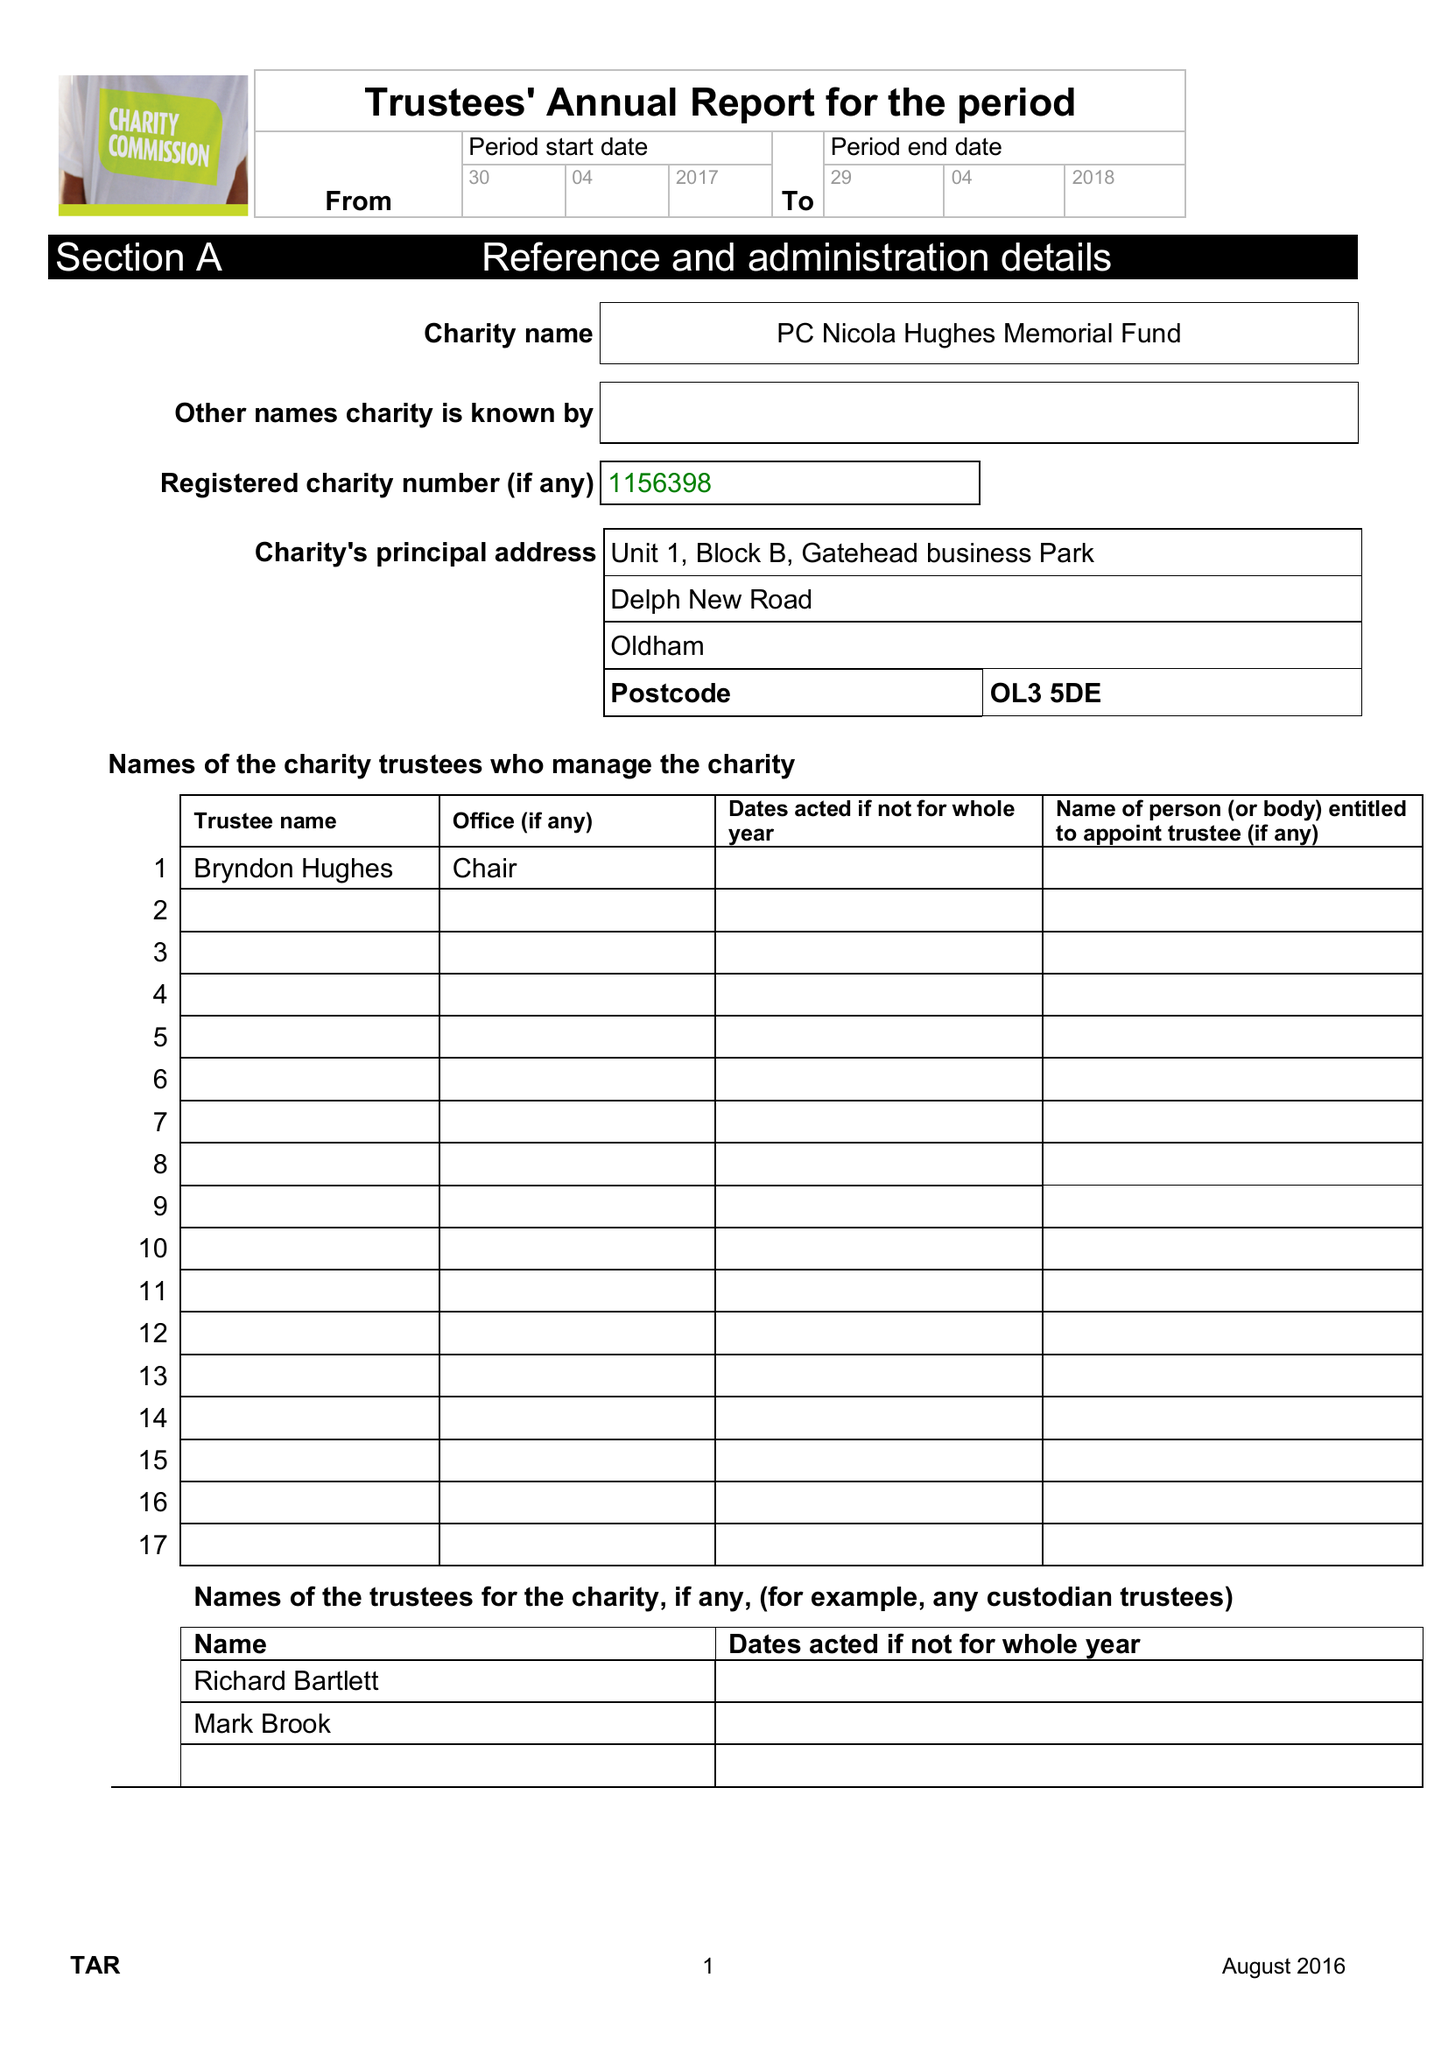What is the value for the address__post_town?
Answer the question using a single word or phrase. OLDHAM 